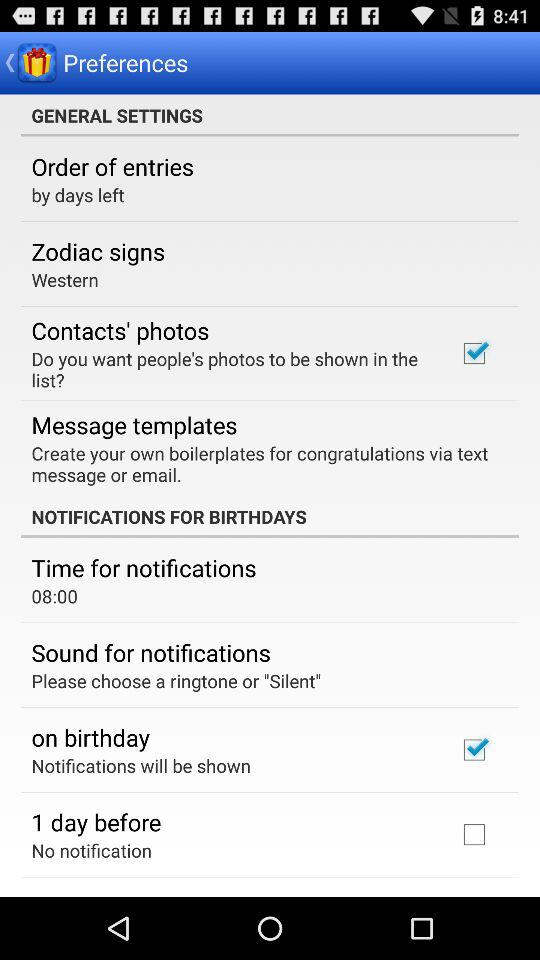Which option is selected for "Zodiac signs"? The option that is selected for "Zodiac signs" is "Western". 